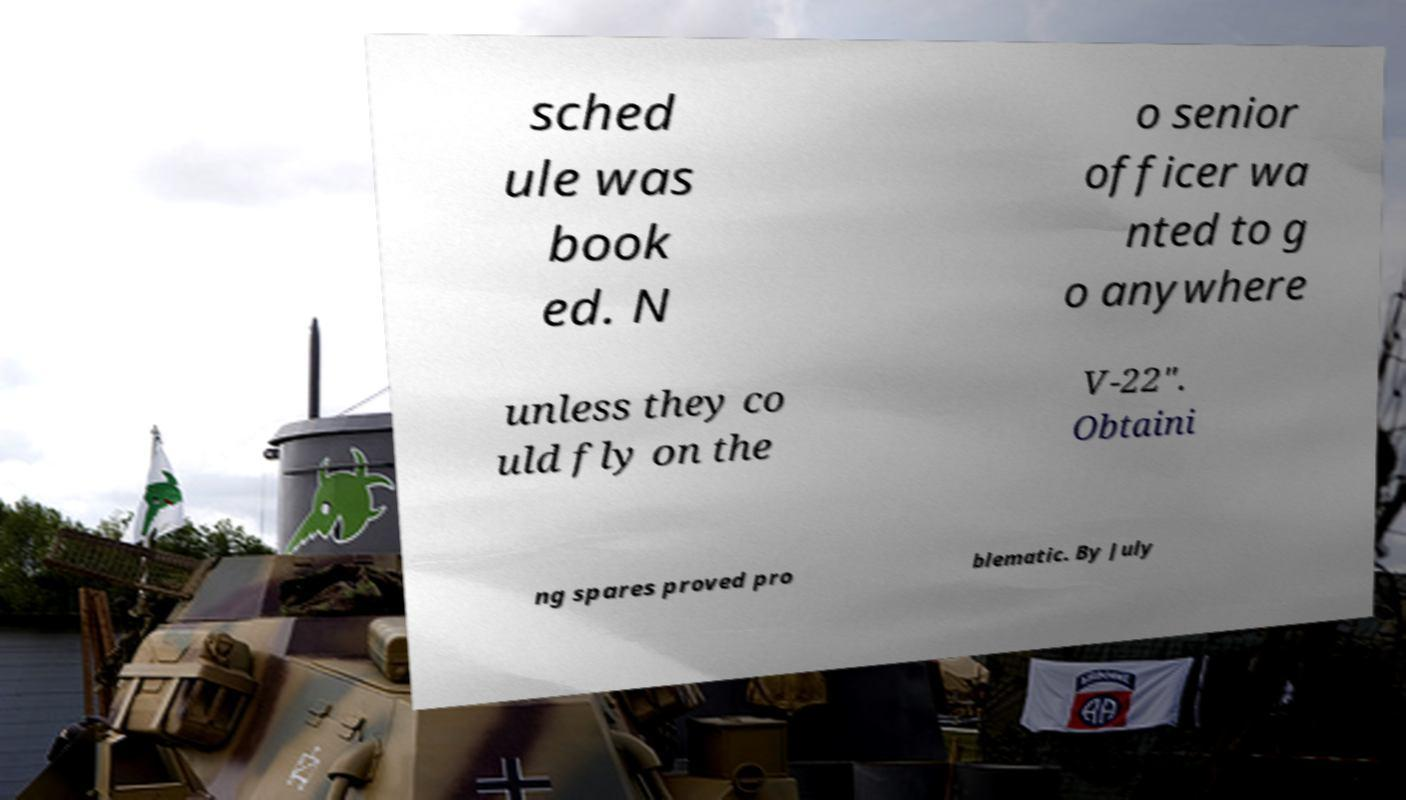Can you read and provide the text displayed in the image?This photo seems to have some interesting text. Can you extract and type it out for me? sched ule was book ed. N o senior officer wa nted to g o anywhere unless they co uld fly on the V-22". Obtaini ng spares proved pro blematic. By July 